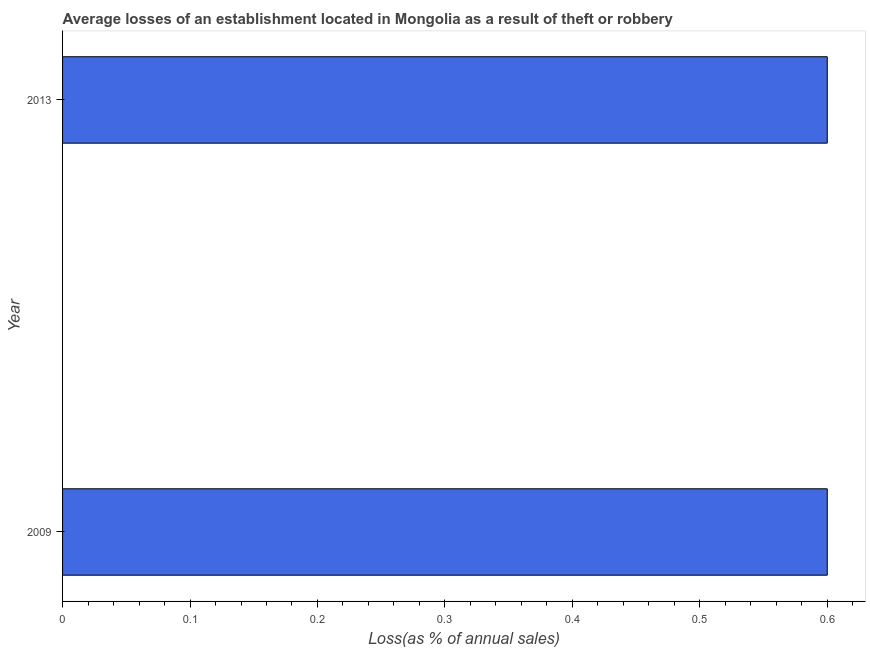What is the title of the graph?
Your response must be concise. Average losses of an establishment located in Mongolia as a result of theft or robbery. What is the label or title of the X-axis?
Make the answer very short. Loss(as % of annual sales). What is the label or title of the Y-axis?
Offer a very short reply. Year. What is the losses due to theft in 2009?
Keep it short and to the point. 0.6. Across all years, what is the maximum losses due to theft?
Provide a short and direct response. 0.6. Across all years, what is the minimum losses due to theft?
Ensure brevity in your answer.  0.6. In which year was the losses due to theft minimum?
Make the answer very short. 2009. What is the difference between the losses due to theft in 2009 and 2013?
Make the answer very short. 0. What is the average losses due to theft per year?
Provide a short and direct response. 0.6. What is the median losses due to theft?
Offer a very short reply. 0.6. What is the ratio of the losses due to theft in 2009 to that in 2013?
Keep it short and to the point. 1. How many bars are there?
Provide a succinct answer. 2. Are the values on the major ticks of X-axis written in scientific E-notation?
Provide a succinct answer. No. What is the difference between the Loss(as % of annual sales) in 2009 and 2013?
Your response must be concise. 0. What is the ratio of the Loss(as % of annual sales) in 2009 to that in 2013?
Make the answer very short. 1. 